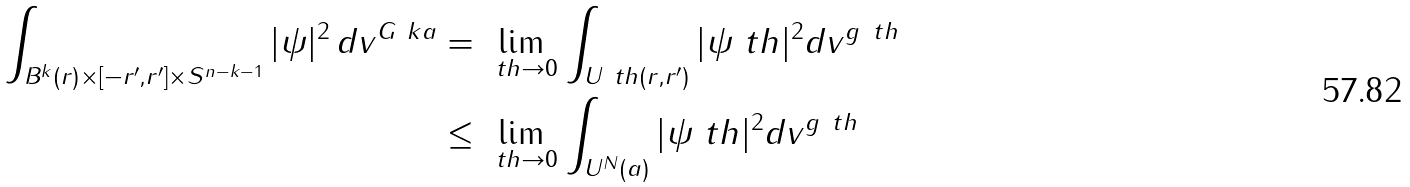<formula> <loc_0><loc_0><loc_500><loc_500>\int _ { B ^ { k } ( r ) \times [ - r ^ { \prime } , r ^ { \prime } ] \times S ^ { n - k - 1 } } | \psi | ^ { 2 } \, d v ^ { G _ { \ } k a } & = \lim _ { \ t h \to 0 } \int _ { U _ { \ } t h ( r , r ^ { \prime } ) } | \psi _ { \ } t h | ^ { 2 } d v ^ { g _ { \ } t h } \\ & \leq \lim _ { \ t h \to 0 } \int _ { U ^ { N } ( a ) } | \psi _ { \ } t h | ^ { 2 } d v ^ { g _ { \ } t h }</formula> 